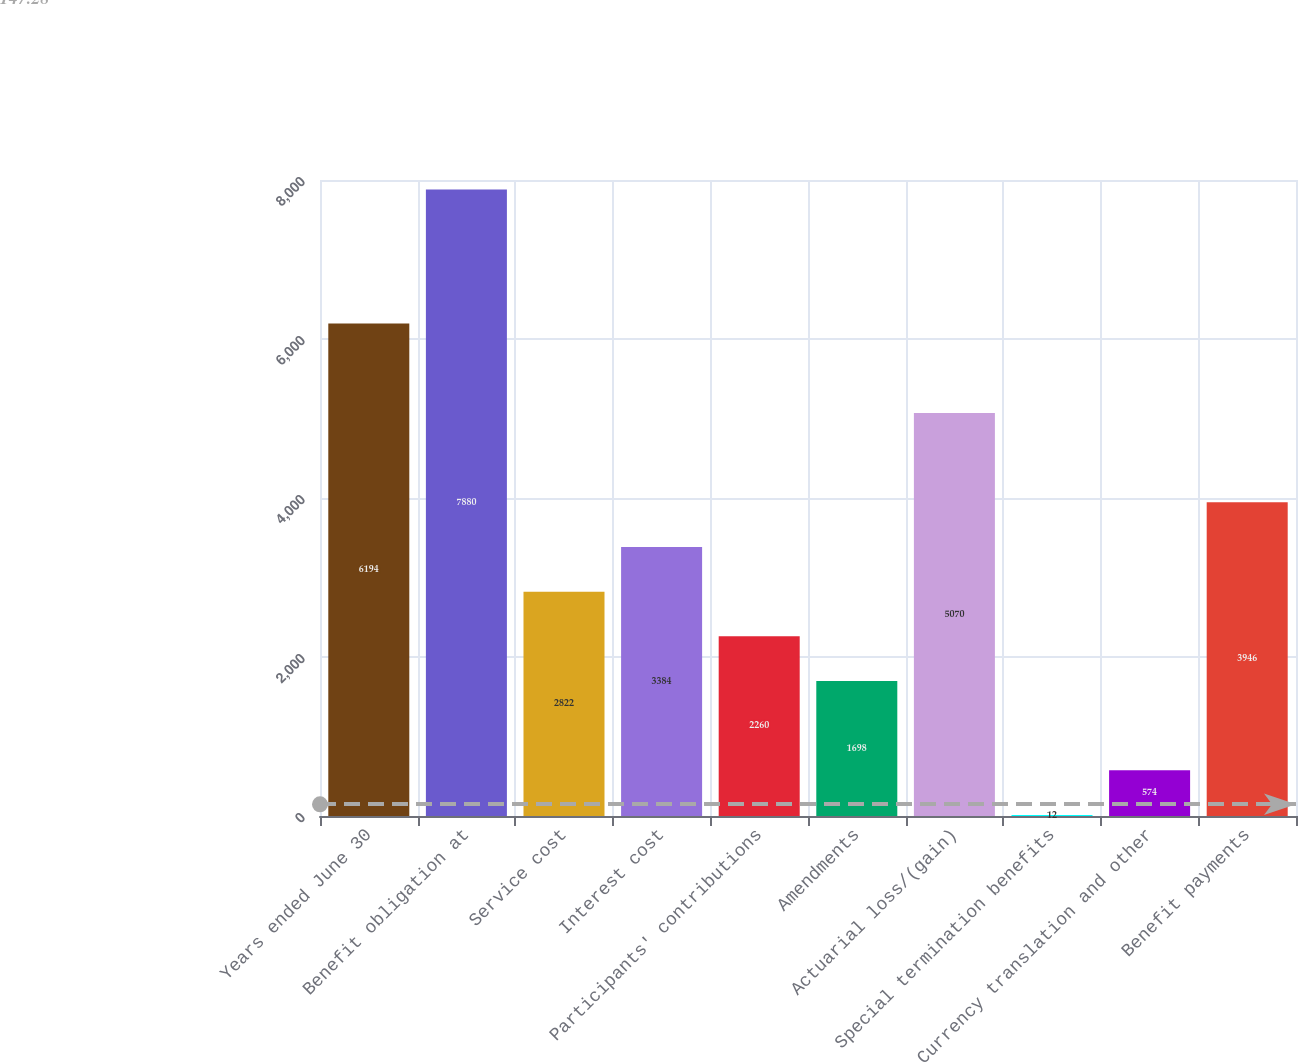Convert chart to OTSL. <chart><loc_0><loc_0><loc_500><loc_500><bar_chart><fcel>Years ended June 30<fcel>Benefit obligation at<fcel>Service cost<fcel>Interest cost<fcel>Participants' contributions<fcel>Amendments<fcel>Actuarial loss/(gain)<fcel>Special termination benefits<fcel>Currency translation and other<fcel>Benefit payments<nl><fcel>6194<fcel>7880<fcel>2822<fcel>3384<fcel>2260<fcel>1698<fcel>5070<fcel>12<fcel>574<fcel>3946<nl></chart> 